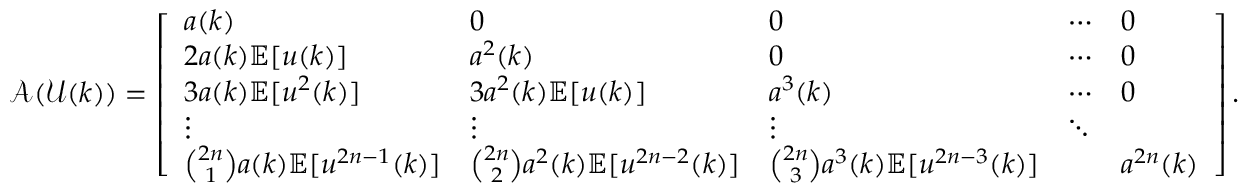<formula> <loc_0><loc_0><loc_500><loc_500>\ m a t h s c r { A } ( \ m a t h s c r { U } ( k ) ) = \left [ \begin{array} { l l l l l } { a ( k ) } & { 0 } & { 0 } & { \cdots } & { 0 } \\ { 2 a ( k ) \mathbb { E } [ u ( k ) ] } & { a ^ { 2 } ( k ) } & { 0 } & { \cdots } & { 0 } \\ { 3 a ( k ) \mathbb { E } [ u ^ { 2 } ( k ) ] } & { 3 a ^ { 2 } ( k ) \mathbb { E } [ u ( k ) ] } & { a ^ { 3 } ( k ) } & { \cdots } & { 0 } \\ { \vdots } & { \vdots } & { \vdots } & { \ddots } \\ { \binom { 2 n } { 1 } a ( k ) \mathbb { E } [ u ^ { 2 n - 1 } ( k ) ] } & { \binom { 2 n } { 2 } a ^ { 2 } ( k ) \mathbb { E } [ u ^ { 2 n - 2 } ( k ) ] } & { \binom { 2 n } { 3 } a ^ { 3 } ( k ) \mathbb { E } [ u ^ { 2 n - 3 } ( k ) ] } & & { a ^ { 2 n } ( k ) } \end{array} \right ] .</formula> 